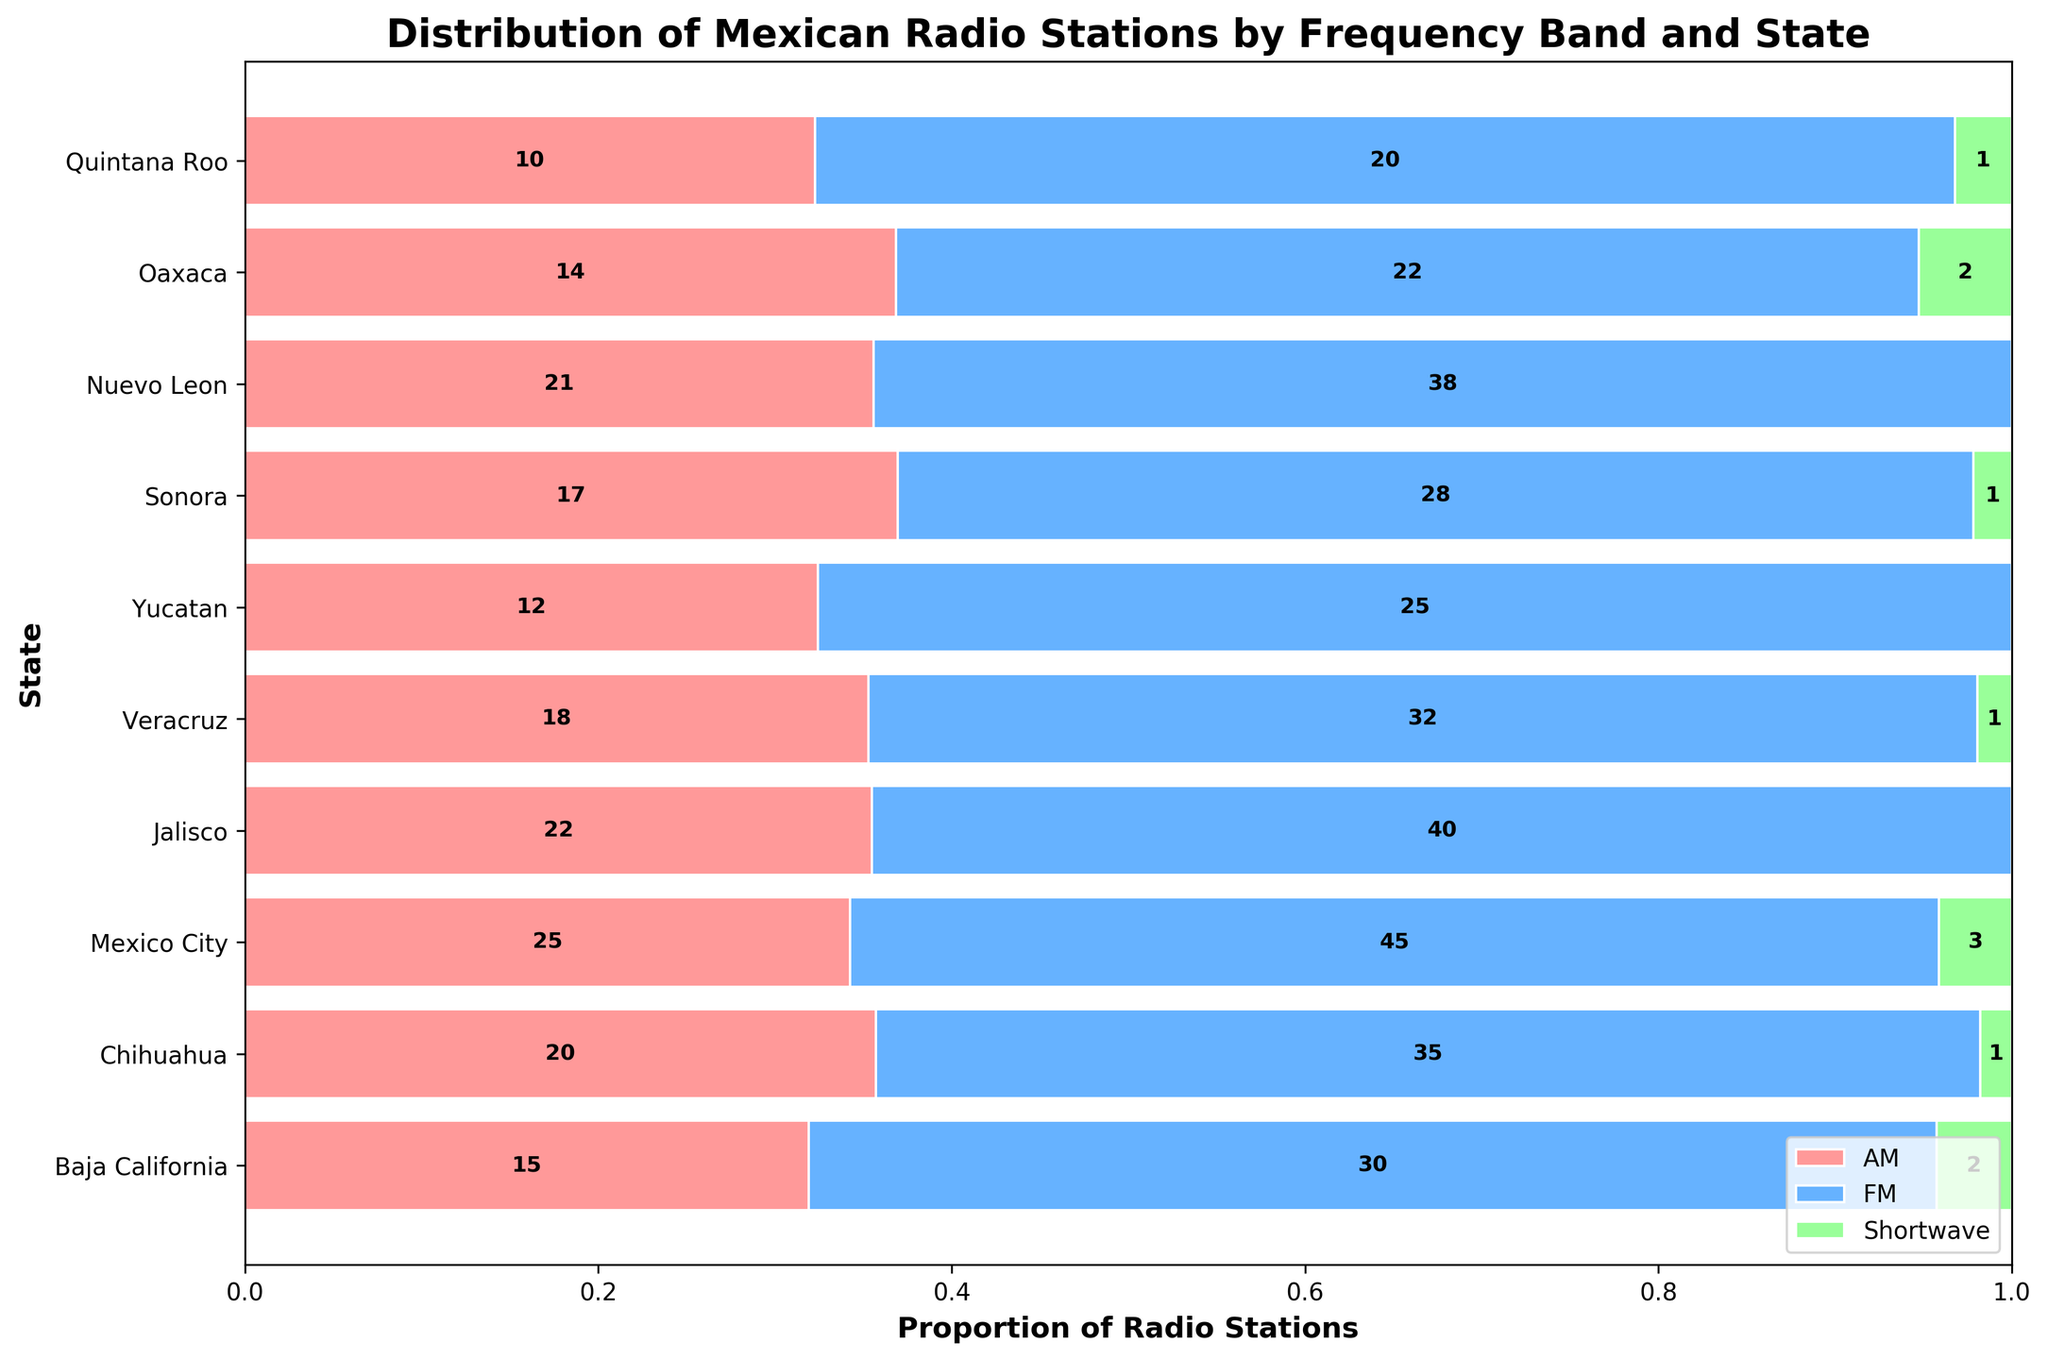Which state has the highest number of FM stations? From the figure, the width of the blue (FM) segment is largest for Mexico City.
Answer: Mexico City What is the proportion of Shortwave stations in Oaxaca? In Oaxaca, count the green section and divide by the total width (AM, FM, Shortwave). Green represents 2, total is 14 (AM) + 22 (FM) + 2 (Shortwave) which equals 38. Thus, 2/38.
Answer: ~5.3% Which states have a similar number of AM and FM stations? Look at the red and blue sections of each state's bar. Yucatan has 12 AM and 25 FM, showing a smaller difference among the others.
Answer: Yucatan How many states have more than 30 FM stations? Identify bars where the blue section exceeds the proportion that 30 represents. Baja California, Chihuahua, Mexico City, Jalisco, Nuevo Leon meet this criteria.
Answer: 5 In which state is the proportion of AM stations higher than the proportion of FM stations? Compare red and blue sections where red is larger. Baja California and Sonora show this.
Answer: Baja California, Sonora What is the total number of radio stations in Quintana Roo? Add the numbers of each band: 10 (AM) + 20 (FM) + 1 (Shortwave) equals 31.
Answer: 31 Which state has the smallest number of AM stations? By comparing the red segments, Quintana Roo, with AM count of 10, is the smallest.
Answer: Quintana Roo Where is the highest number of Shortwave stations found? Look at the green segments. Mexico City has three, the highest in the data.
Answer: Mexico City What is the total number of FM stations in Mexico City and Nuevo Leon combined? Add FM stations of both: 45 (Mexico City) + 38 (Nuevo Leon) equals 83.
Answer: 83 Which state has the smallest combined AM and Shortwave station count? Sum the red and green sections for each state. Yucatan has (12+0=12) stations in this combined category, the lowest.
Answer: Yucatan 